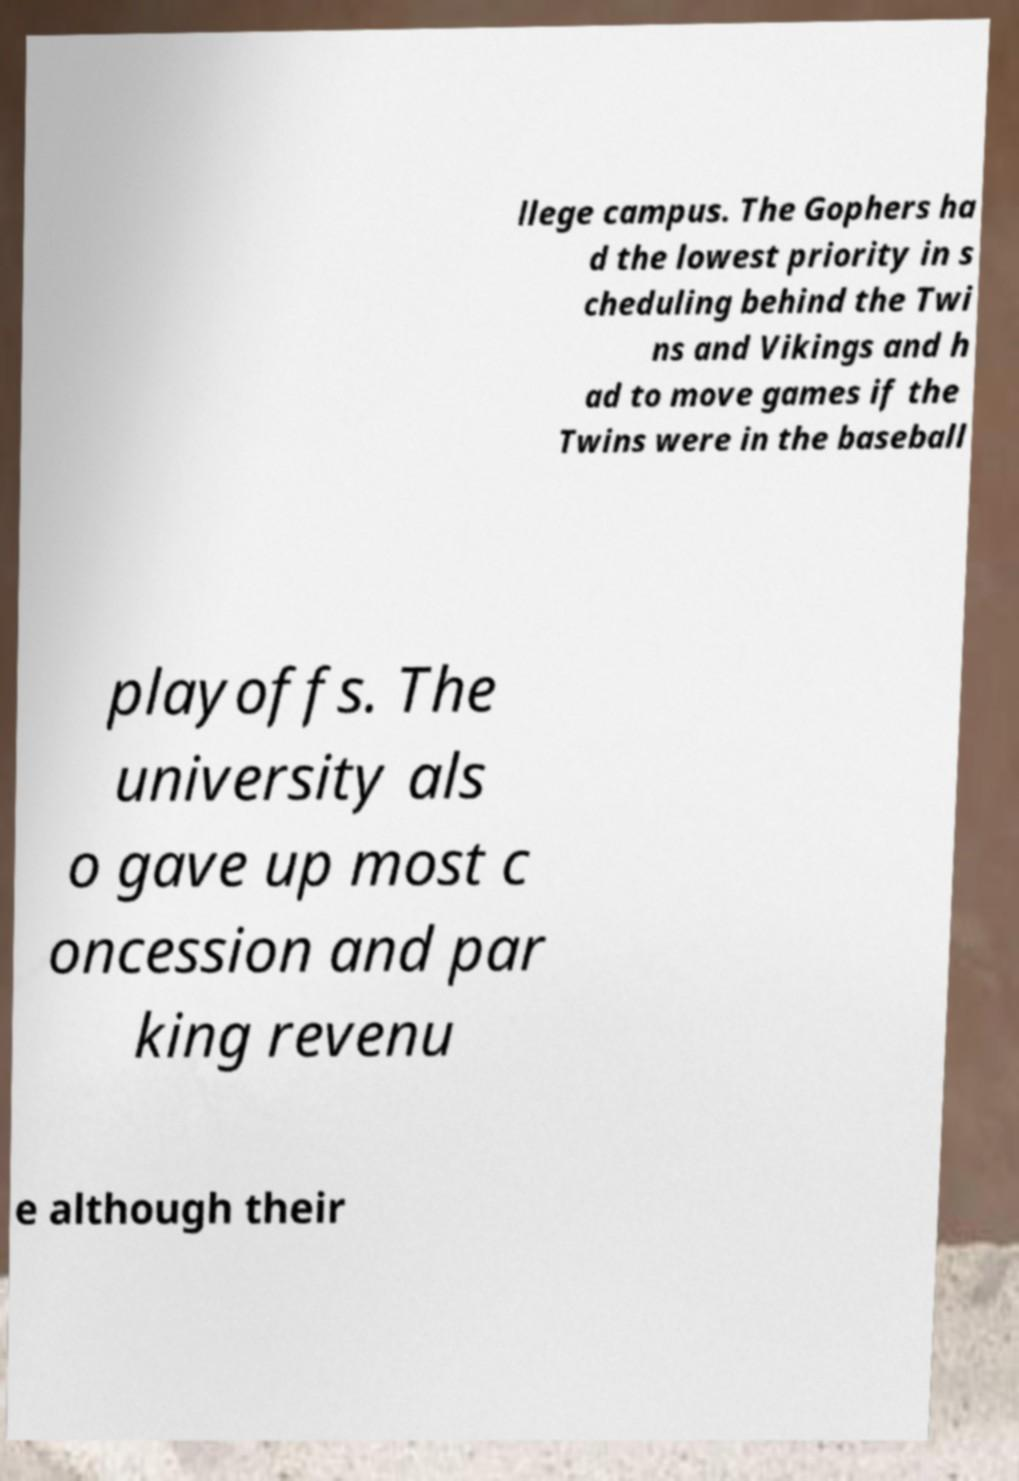There's text embedded in this image that I need extracted. Can you transcribe it verbatim? llege campus. The Gophers ha d the lowest priority in s cheduling behind the Twi ns and Vikings and h ad to move games if the Twins were in the baseball playoffs. The university als o gave up most c oncession and par king revenu e although their 